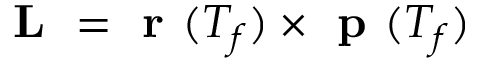<formula> <loc_0><loc_0><loc_500><loc_500>L = r ( T _ { f } ) \times p ( T _ { f } )</formula> 